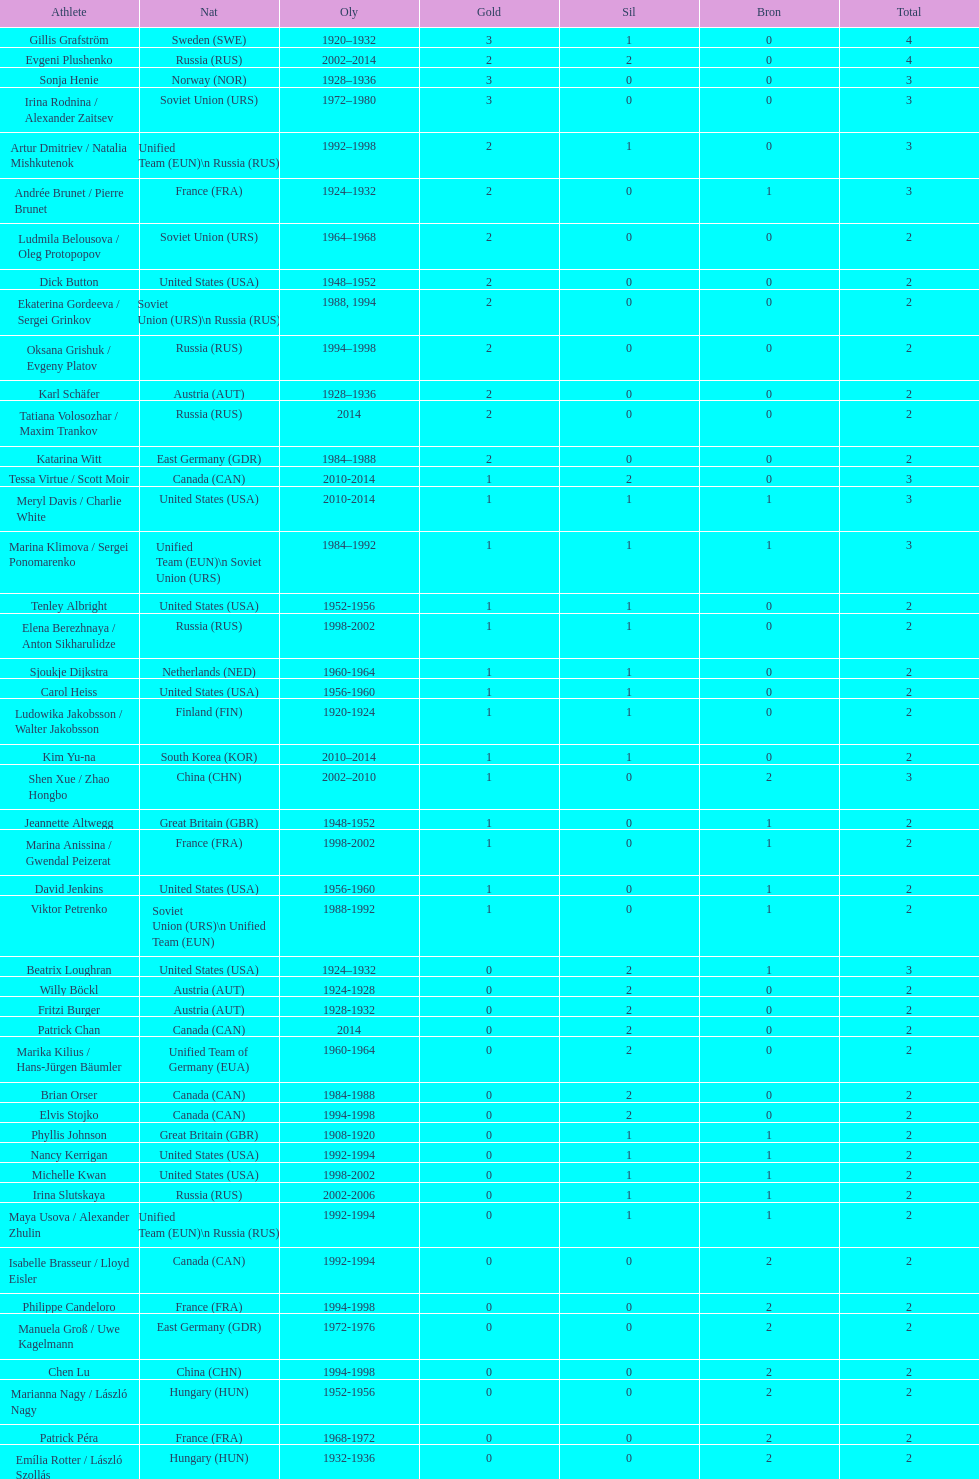How many total medals has the united states won in women's figure skating? 16. 